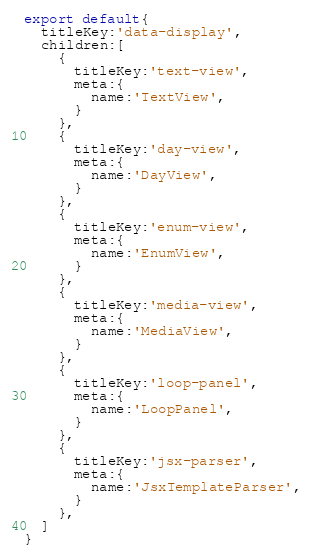Convert code to text. <code><loc_0><loc_0><loc_500><loc_500><_TypeScript_>export default{
  titleKey:'data-display',
  children:[
    {
      titleKey:'text-view',
      meta:{
        name:'TextView',
      }
    },
    {
      titleKey:'day-view',
      meta:{
        name:'DayView',
      }
    },
    {
      titleKey:'enum-view',
      meta:{
        name:'EnumView',
      }
    },
    {
      titleKey:'media-view',
      meta:{
        name:'MediaView',
      }
    },
    {
      titleKey:'loop-panel',
      meta:{
        name:'LoopPanel',
      }
    },
    {
      titleKey:'jsx-parser',
      meta:{
        name:'JsxTemplateParser',
      }
    },
  ]
}</code> 